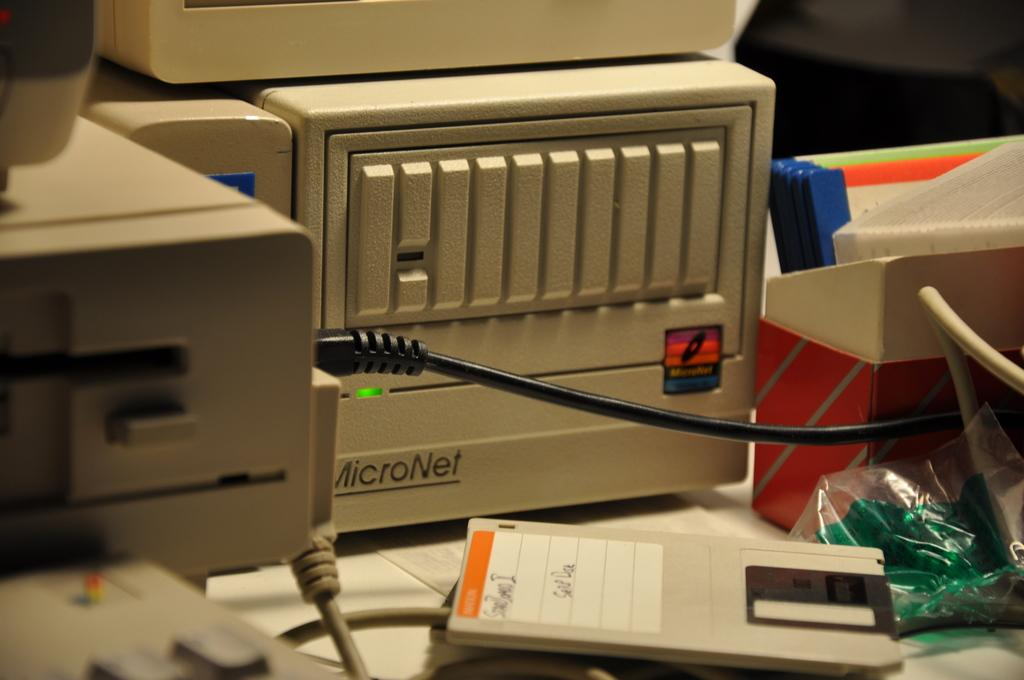Provide a one-sentence caption for the provided image. A Micronet Tower on a desk with a floppy disc in from to it. 